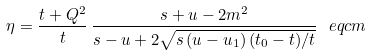<formula> <loc_0><loc_0><loc_500><loc_500>\eta = \frac { t + Q ^ { 2 } } { t } \, \frac { s + u - 2 m ^ { 2 } } { s - u + 2 \sqrt { s \, ( u - u _ { 1 } ) \, ( t _ { 0 } - t ) / t } } \ e q c m</formula> 